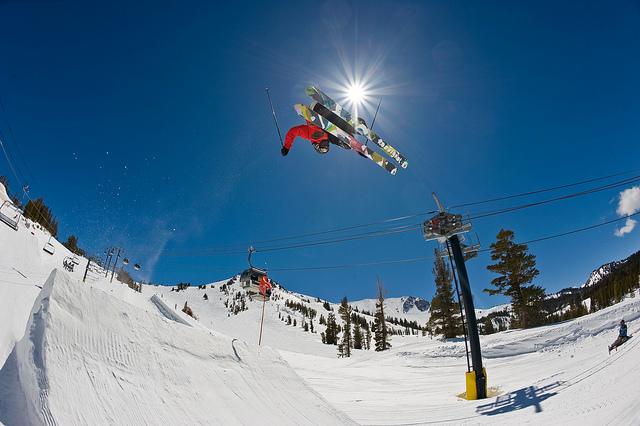Is the sun shining?
Give a very brief answer. Yes. Is snow on the ground?
Write a very short answer. Yes. What color is the skiers jacket?
Write a very short answer. Red. 